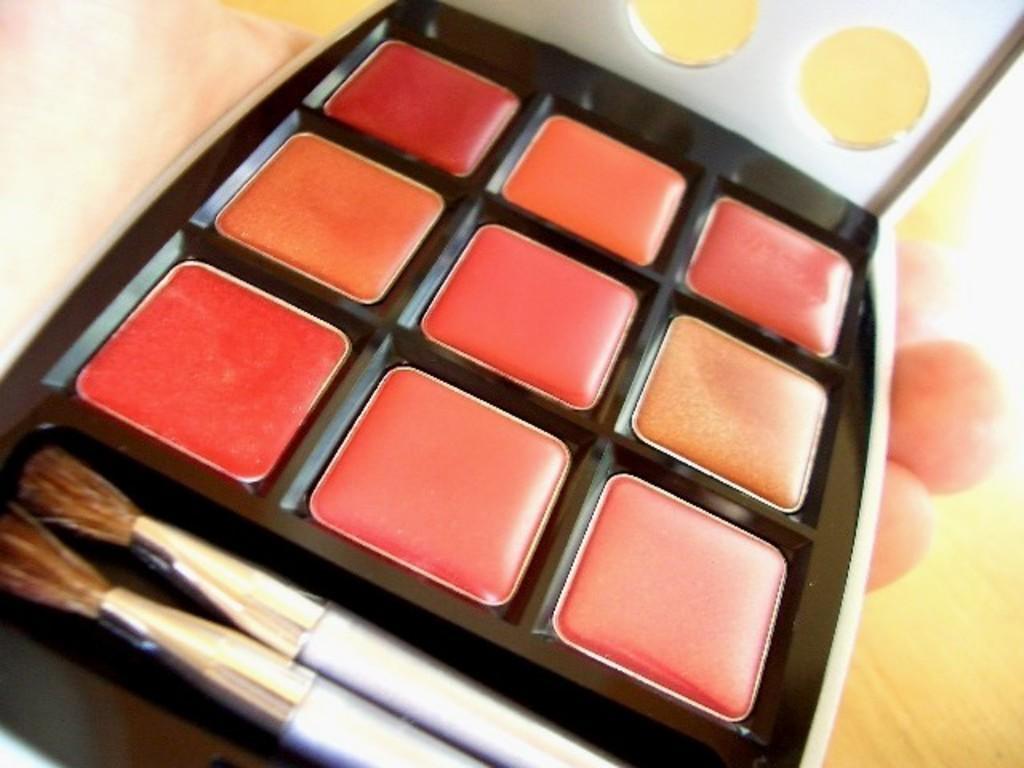Could you give a brief overview of what you see in this image? Here we can see a makeup box and two brushes in it in a person hand and this is floor. 